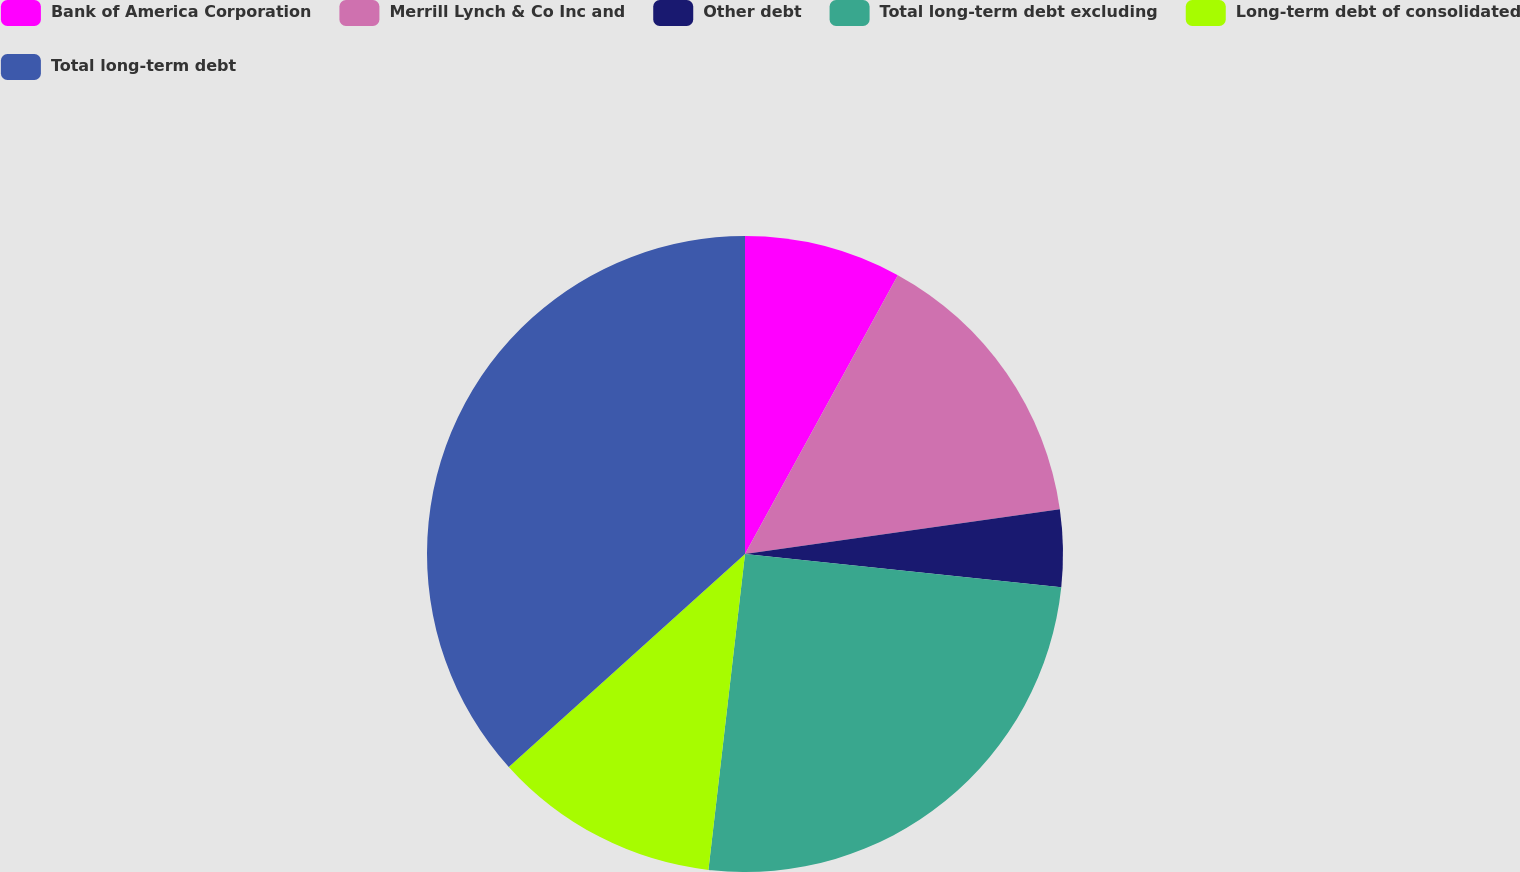Convert chart to OTSL. <chart><loc_0><loc_0><loc_500><loc_500><pie_chart><fcel>Bank of America Corporation<fcel>Merrill Lynch & Co Inc and<fcel>Other debt<fcel>Total long-term debt excluding<fcel>Long-term debt of consolidated<fcel>Total long-term debt<nl><fcel>7.98%<fcel>14.77%<fcel>3.91%<fcel>25.17%<fcel>11.49%<fcel>36.67%<nl></chart> 